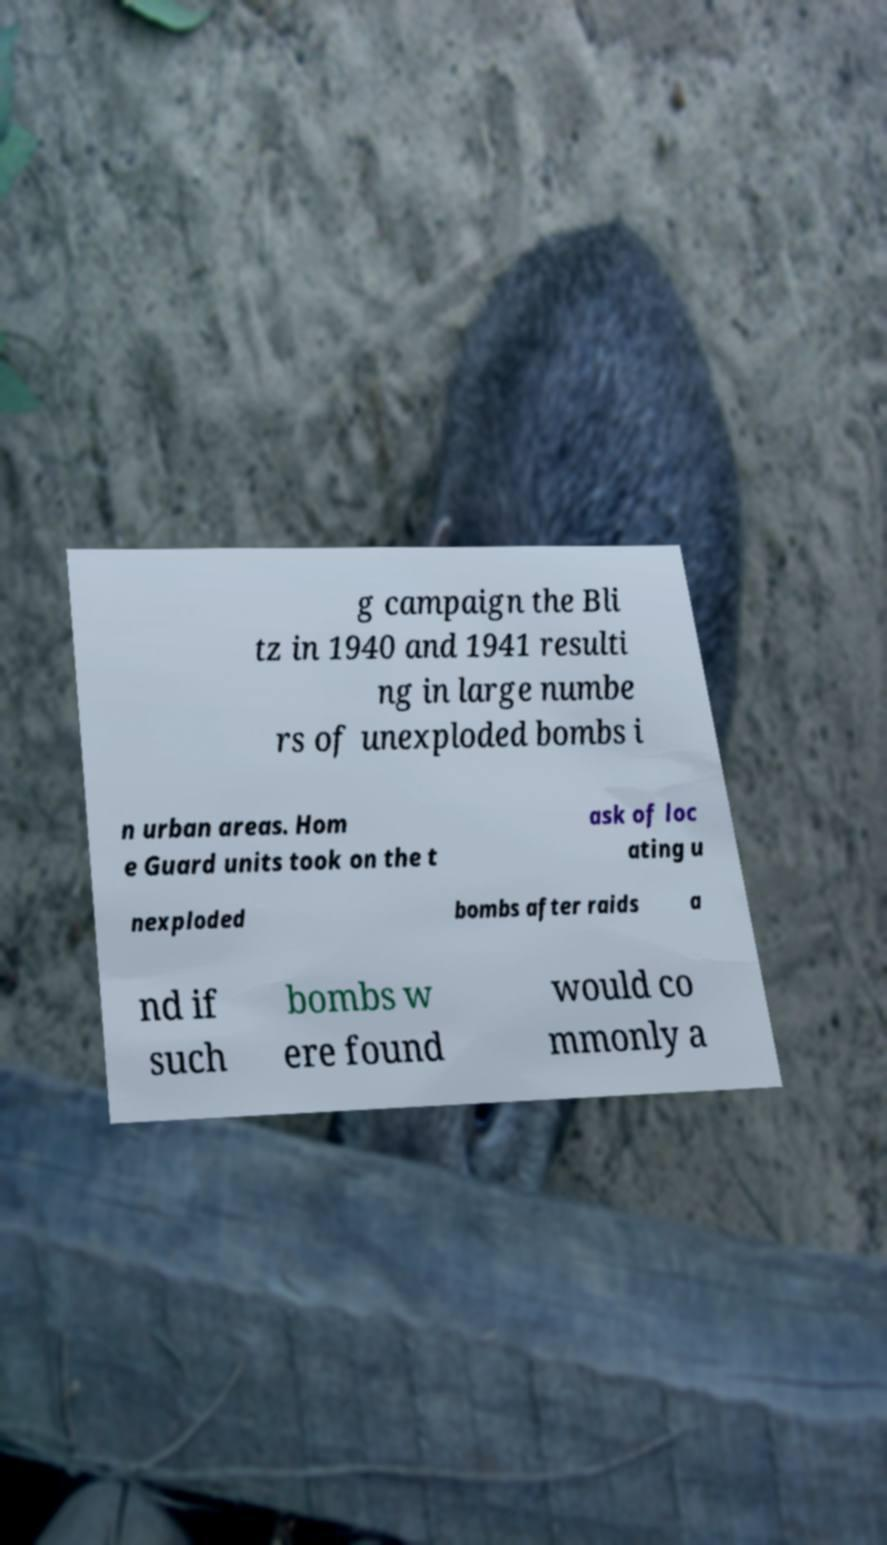Could you assist in decoding the text presented in this image and type it out clearly? g campaign the Bli tz in 1940 and 1941 resulti ng in large numbe rs of unexploded bombs i n urban areas. Hom e Guard units took on the t ask of loc ating u nexploded bombs after raids a nd if such bombs w ere found would co mmonly a 